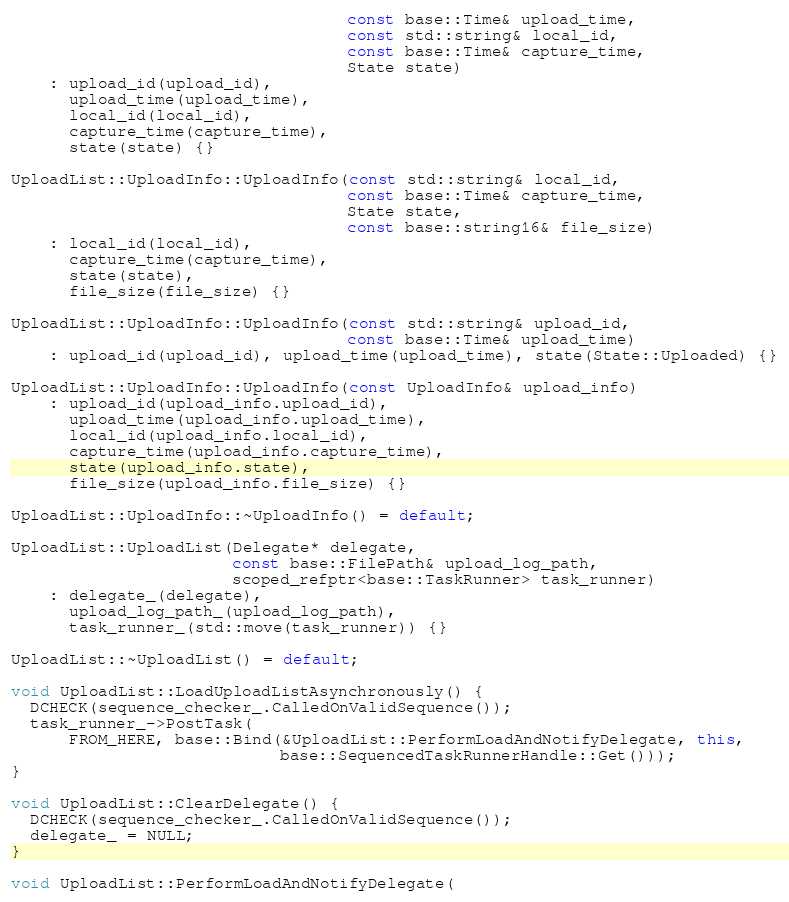Convert code to text. <code><loc_0><loc_0><loc_500><loc_500><_C++_>                                   const base::Time& upload_time,
                                   const std::string& local_id,
                                   const base::Time& capture_time,
                                   State state)
    : upload_id(upload_id),
      upload_time(upload_time),
      local_id(local_id),
      capture_time(capture_time),
      state(state) {}

UploadList::UploadInfo::UploadInfo(const std::string& local_id,
                                   const base::Time& capture_time,
                                   State state,
                                   const base::string16& file_size)
    : local_id(local_id),
      capture_time(capture_time),
      state(state),
      file_size(file_size) {}

UploadList::UploadInfo::UploadInfo(const std::string& upload_id,
                                   const base::Time& upload_time)
    : upload_id(upload_id), upload_time(upload_time), state(State::Uploaded) {}

UploadList::UploadInfo::UploadInfo(const UploadInfo& upload_info)
    : upload_id(upload_info.upload_id),
      upload_time(upload_info.upload_time),
      local_id(upload_info.local_id),
      capture_time(upload_info.capture_time),
      state(upload_info.state),
      file_size(upload_info.file_size) {}

UploadList::UploadInfo::~UploadInfo() = default;

UploadList::UploadList(Delegate* delegate,
                       const base::FilePath& upload_log_path,
                       scoped_refptr<base::TaskRunner> task_runner)
    : delegate_(delegate),
      upload_log_path_(upload_log_path),
      task_runner_(std::move(task_runner)) {}

UploadList::~UploadList() = default;

void UploadList::LoadUploadListAsynchronously() {
  DCHECK(sequence_checker_.CalledOnValidSequence());
  task_runner_->PostTask(
      FROM_HERE, base::Bind(&UploadList::PerformLoadAndNotifyDelegate, this,
                            base::SequencedTaskRunnerHandle::Get()));
}

void UploadList::ClearDelegate() {
  DCHECK(sequence_checker_.CalledOnValidSequence());
  delegate_ = NULL;
}

void UploadList::PerformLoadAndNotifyDelegate(</code> 